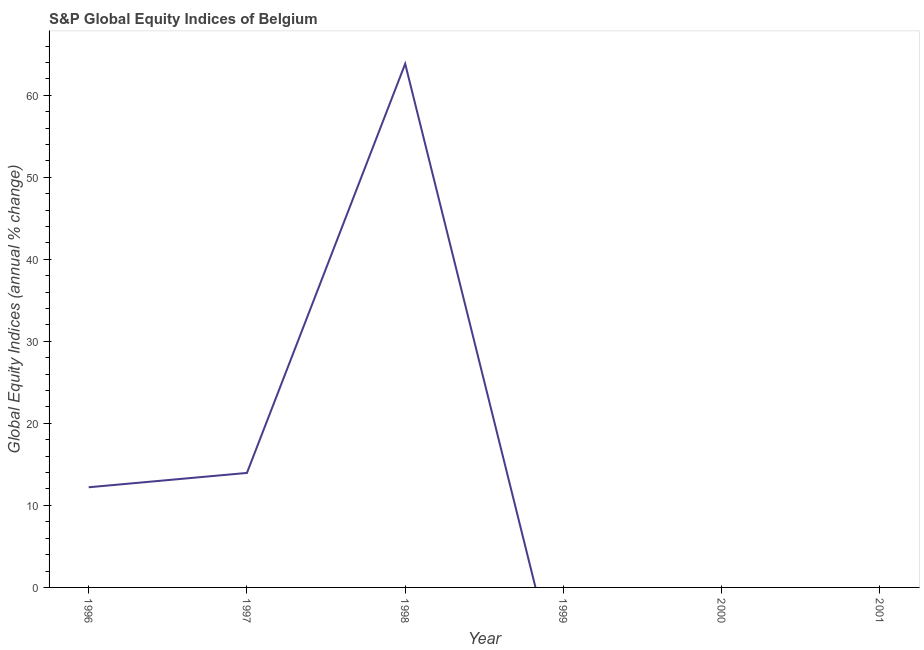Across all years, what is the maximum s&p global equity indices?
Give a very brief answer. 63.83. Across all years, what is the minimum s&p global equity indices?
Offer a very short reply. 0. In which year was the s&p global equity indices maximum?
Give a very brief answer. 1998. What is the sum of the s&p global equity indices?
Keep it short and to the point. 90. What is the difference between the s&p global equity indices in 1996 and 1997?
Make the answer very short. -1.75. What is the average s&p global equity indices per year?
Offer a terse response. 15. What is the median s&p global equity indices?
Your answer should be compact. 6.11. Is the s&p global equity indices in 1997 less than that in 1998?
Make the answer very short. Yes. Is the difference between the s&p global equity indices in 1996 and 1997 greater than the difference between any two years?
Your answer should be compact. No. What is the difference between the highest and the second highest s&p global equity indices?
Ensure brevity in your answer.  49.87. Is the sum of the s&p global equity indices in 1996 and 1998 greater than the maximum s&p global equity indices across all years?
Provide a succinct answer. Yes. What is the difference between the highest and the lowest s&p global equity indices?
Provide a succinct answer. 63.83. How many lines are there?
Your answer should be very brief. 1. How many years are there in the graph?
Provide a succinct answer. 6. Are the values on the major ticks of Y-axis written in scientific E-notation?
Your answer should be compact. No. Does the graph contain grids?
Give a very brief answer. No. What is the title of the graph?
Your answer should be compact. S&P Global Equity Indices of Belgium. What is the label or title of the Y-axis?
Keep it short and to the point. Global Equity Indices (annual % change). What is the Global Equity Indices (annual % change) in 1996?
Your response must be concise. 12.21. What is the Global Equity Indices (annual % change) in 1997?
Offer a very short reply. 13.96. What is the Global Equity Indices (annual % change) in 1998?
Provide a succinct answer. 63.83. What is the Global Equity Indices (annual % change) of 2000?
Make the answer very short. 0. What is the difference between the Global Equity Indices (annual % change) in 1996 and 1997?
Provide a short and direct response. -1.75. What is the difference between the Global Equity Indices (annual % change) in 1996 and 1998?
Offer a very short reply. -51.62. What is the difference between the Global Equity Indices (annual % change) in 1997 and 1998?
Keep it short and to the point. -49.87. What is the ratio of the Global Equity Indices (annual % change) in 1996 to that in 1998?
Give a very brief answer. 0.19. What is the ratio of the Global Equity Indices (annual % change) in 1997 to that in 1998?
Keep it short and to the point. 0.22. 